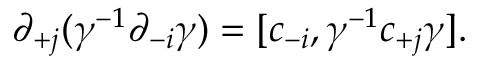<formula> <loc_0><loc_0><loc_500><loc_500>\partial _ { + j } ( \gamma ^ { - 1 } \partial _ { - i } \gamma ) = [ c _ { - i } , \gamma ^ { - 1 } c _ { + j } \gamma ] .</formula> 